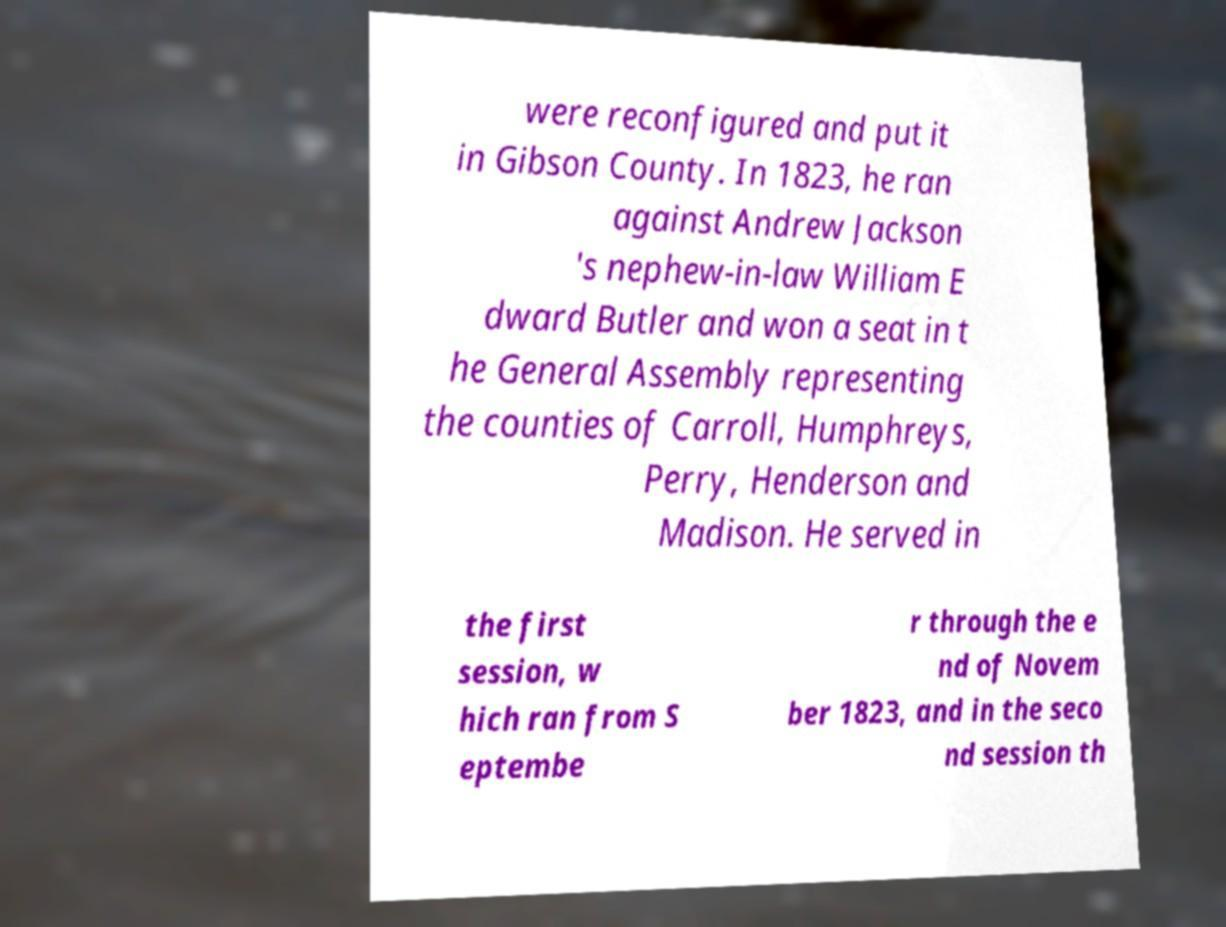Please read and relay the text visible in this image. What does it say? were reconfigured and put it in Gibson County. In 1823, he ran against Andrew Jackson 's nephew-in-law William E dward Butler and won a seat in t he General Assembly representing the counties of Carroll, Humphreys, Perry, Henderson and Madison. He served in the first session, w hich ran from S eptembe r through the e nd of Novem ber 1823, and in the seco nd session th 